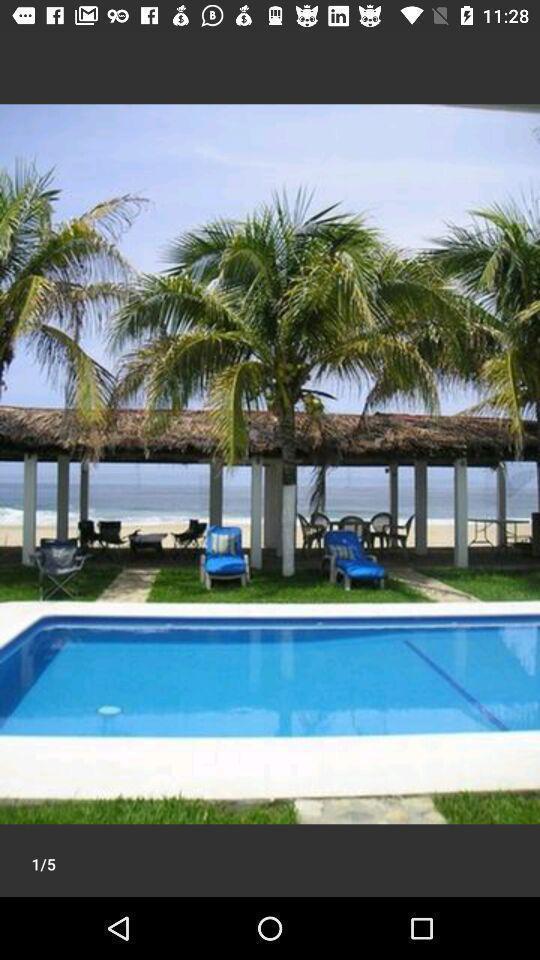Provide a detailed account of this screenshot. Page showing image of a swimming pool. What details can you identify in this image? Screen showing the image in travel app. 